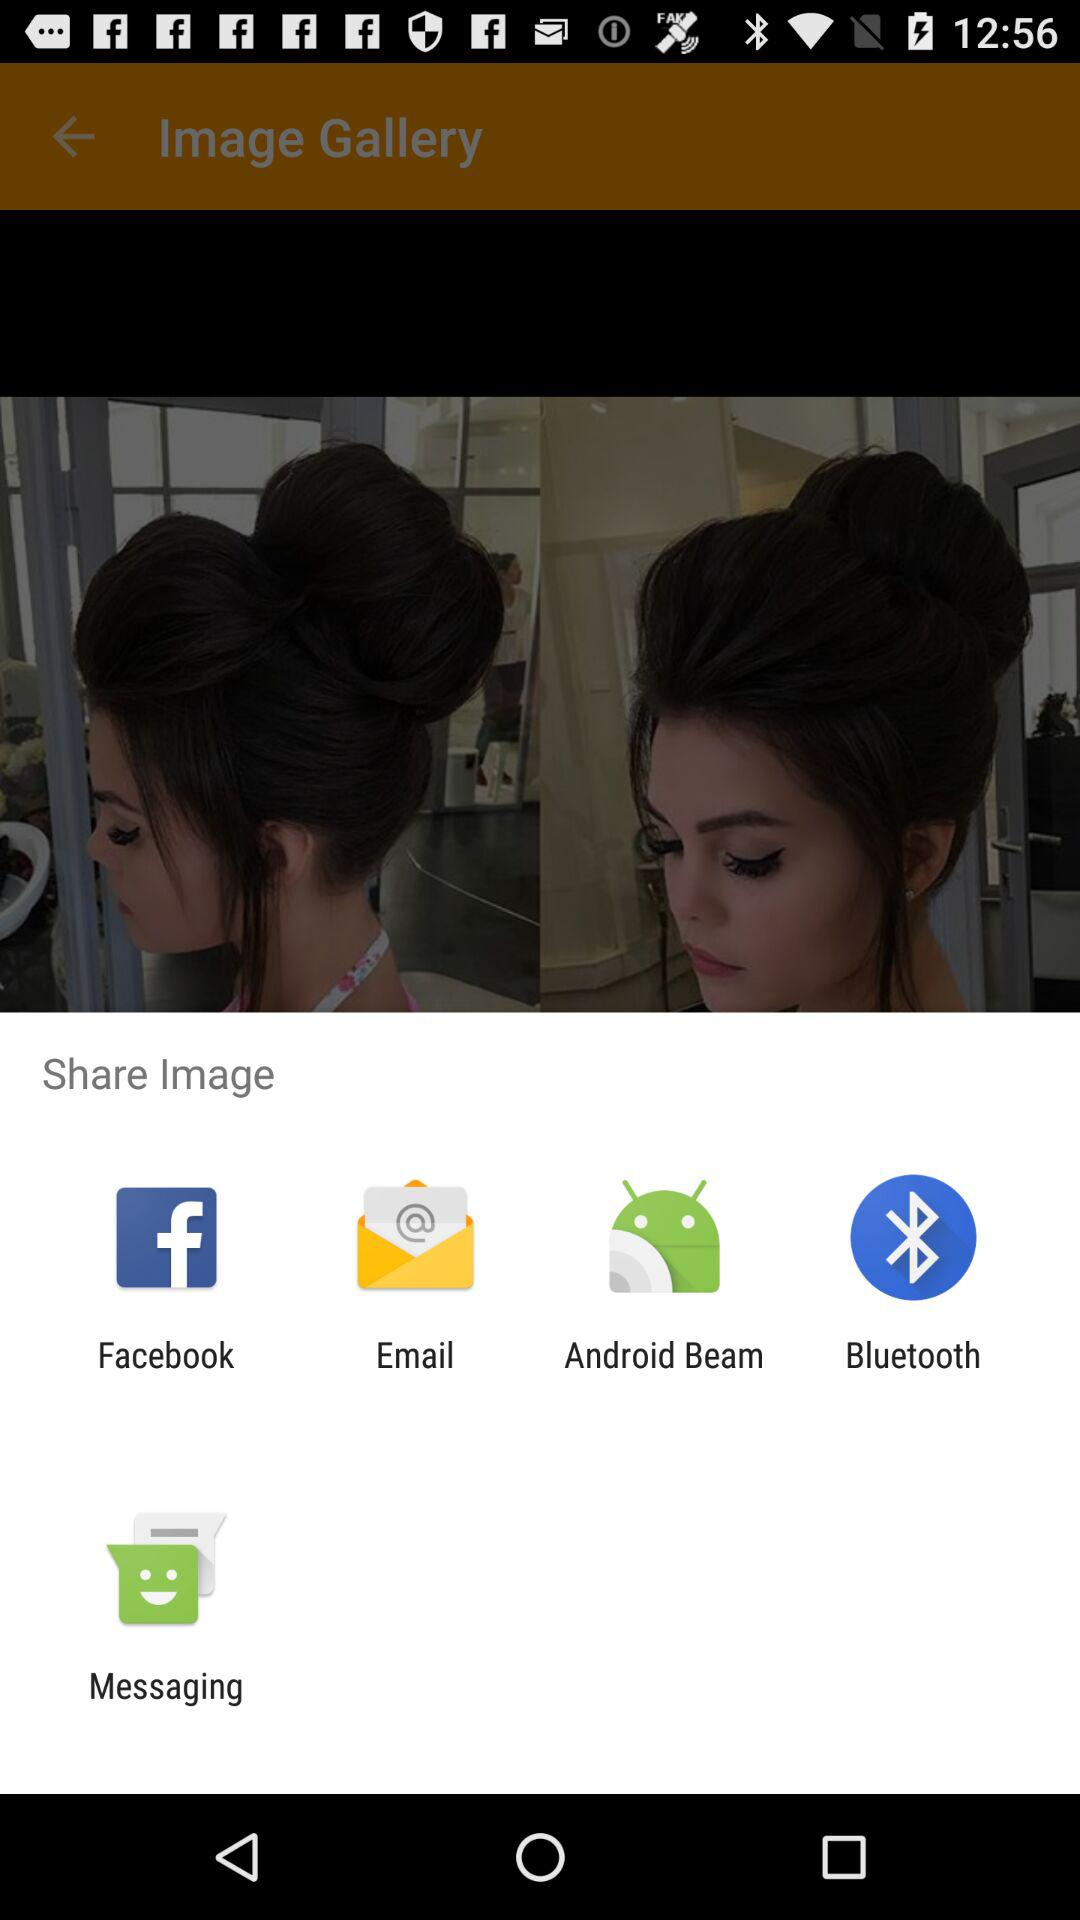How many more share options are there than messaging options?
Answer the question using a single word or phrase. 3 